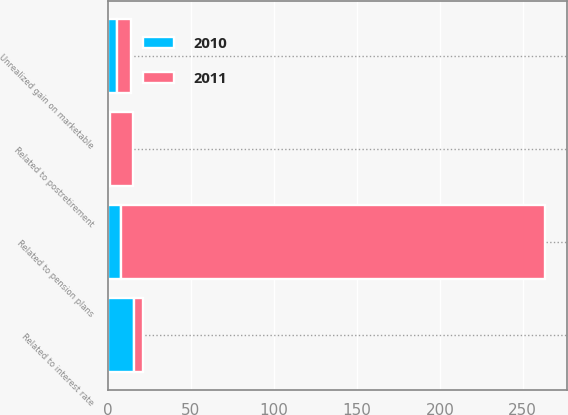<chart> <loc_0><loc_0><loc_500><loc_500><stacked_bar_chart><ecel><fcel>Unrealized gain on marketable<fcel>Related to pension plans<fcel>Related to postretirement<fcel>Related to interest rate<nl><fcel>2010<fcel>5.7<fcel>8<fcel>1<fcel>15.7<nl><fcel>2011<fcel>8<fcel>255.4<fcel>14.3<fcel>5.5<nl></chart> 